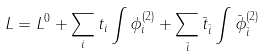<formula> <loc_0><loc_0><loc_500><loc_500>L = L ^ { 0 } + \sum _ { i } t _ { i } \int \phi _ { i } ^ { ( 2 ) } + \sum _ { \bar { i } } \bar { t } _ { \bar { i } } \int \bar { \phi } _ { \bar { i } } ^ { ( 2 ) }</formula> 